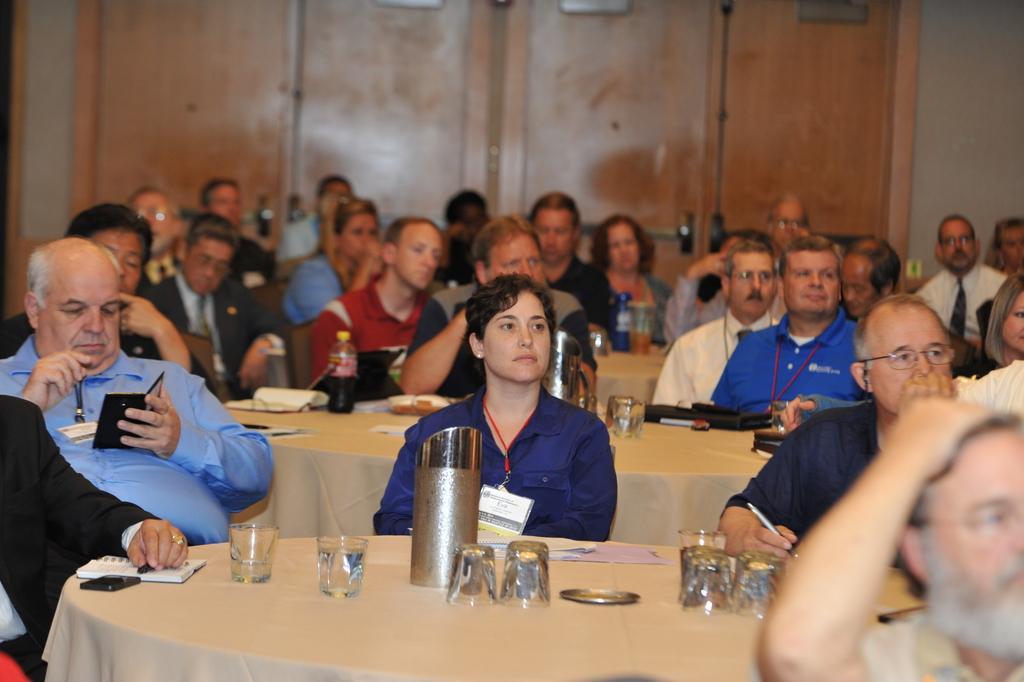Could you give a brief overview of what you see in this image? In this picture we can see a group of people sitting on chairs and some are holding mobiles, pens in their hands and in front of them on table w e have glass, jars, papers, book, pen, bottle and in background we can see wall, pipe. 